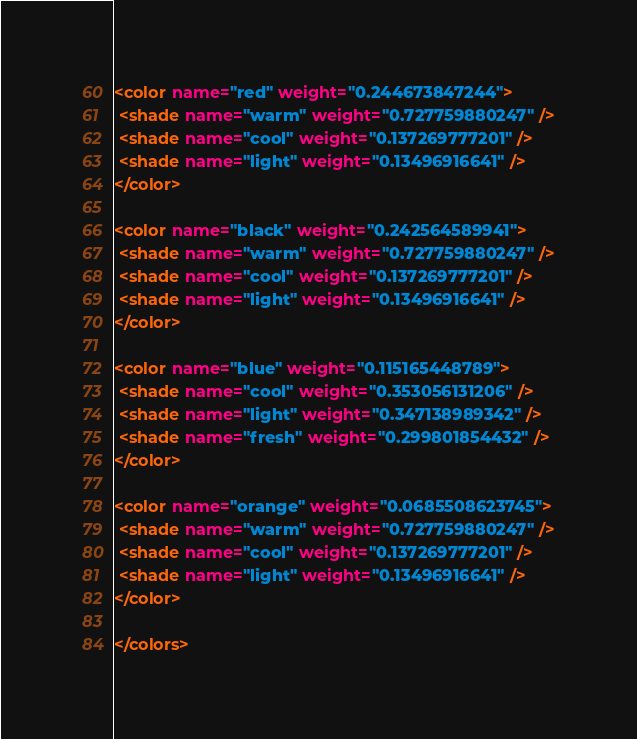Convert code to text. <code><loc_0><loc_0><loc_500><loc_500><_XML_><color name="red" weight="0.244673847244">
 <shade name="warm" weight="0.727759880247" />
 <shade name="cool" weight="0.137269777201" />
 <shade name="light" weight="0.13496916641" />
</color>

<color name="black" weight="0.242564589941">
 <shade name="warm" weight="0.727759880247" />
 <shade name="cool" weight="0.137269777201" />
 <shade name="light" weight="0.13496916641" />
</color>

<color name="blue" weight="0.115165448789">
 <shade name="cool" weight="0.353056131206" />
 <shade name="light" weight="0.347138989342" />
 <shade name="fresh" weight="0.299801854432" />
</color>

<color name="orange" weight="0.0685508623745">
 <shade name="warm" weight="0.727759880247" />
 <shade name="cool" weight="0.137269777201" />
 <shade name="light" weight="0.13496916641" />
</color>

</colors></code> 